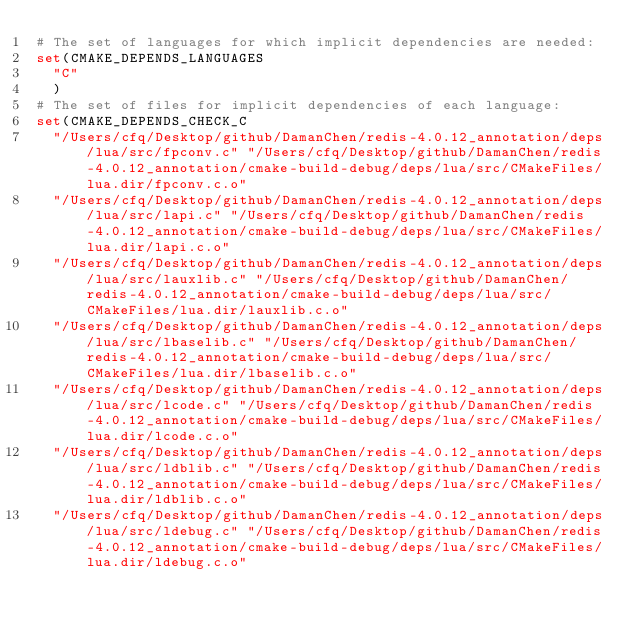Convert code to text. <code><loc_0><loc_0><loc_500><loc_500><_CMake_># The set of languages for which implicit dependencies are needed:
set(CMAKE_DEPENDS_LANGUAGES
  "C"
  )
# The set of files for implicit dependencies of each language:
set(CMAKE_DEPENDS_CHECK_C
  "/Users/cfq/Desktop/github/DamanChen/redis-4.0.12_annotation/deps/lua/src/fpconv.c" "/Users/cfq/Desktop/github/DamanChen/redis-4.0.12_annotation/cmake-build-debug/deps/lua/src/CMakeFiles/lua.dir/fpconv.c.o"
  "/Users/cfq/Desktop/github/DamanChen/redis-4.0.12_annotation/deps/lua/src/lapi.c" "/Users/cfq/Desktop/github/DamanChen/redis-4.0.12_annotation/cmake-build-debug/deps/lua/src/CMakeFiles/lua.dir/lapi.c.o"
  "/Users/cfq/Desktop/github/DamanChen/redis-4.0.12_annotation/deps/lua/src/lauxlib.c" "/Users/cfq/Desktop/github/DamanChen/redis-4.0.12_annotation/cmake-build-debug/deps/lua/src/CMakeFiles/lua.dir/lauxlib.c.o"
  "/Users/cfq/Desktop/github/DamanChen/redis-4.0.12_annotation/deps/lua/src/lbaselib.c" "/Users/cfq/Desktop/github/DamanChen/redis-4.0.12_annotation/cmake-build-debug/deps/lua/src/CMakeFiles/lua.dir/lbaselib.c.o"
  "/Users/cfq/Desktop/github/DamanChen/redis-4.0.12_annotation/deps/lua/src/lcode.c" "/Users/cfq/Desktop/github/DamanChen/redis-4.0.12_annotation/cmake-build-debug/deps/lua/src/CMakeFiles/lua.dir/lcode.c.o"
  "/Users/cfq/Desktop/github/DamanChen/redis-4.0.12_annotation/deps/lua/src/ldblib.c" "/Users/cfq/Desktop/github/DamanChen/redis-4.0.12_annotation/cmake-build-debug/deps/lua/src/CMakeFiles/lua.dir/ldblib.c.o"
  "/Users/cfq/Desktop/github/DamanChen/redis-4.0.12_annotation/deps/lua/src/ldebug.c" "/Users/cfq/Desktop/github/DamanChen/redis-4.0.12_annotation/cmake-build-debug/deps/lua/src/CMakeFiles/lua.dir/ldebug.c.o"</code> 